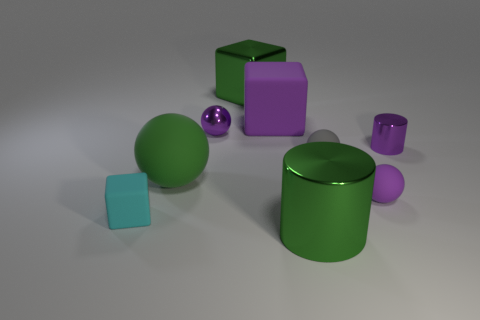What is the material of the big object that is the same color as the metal sphere?
Provide a short and direct response. Rubber. What is the size of the cylinder that is the same color as the large sphere?
Give a very brief answer. Large. There is a large rubber object that is right of the green cube; is its color the same as the cylinder behind the tiny cyan matte thing?
Offer a very short reply. Yes. Is there any other thing that has the same color as the small cylinder?
Provide a succinct answer. Yes. Does the big matte sphere have the same color as the big metal cylinder?
Make the answer very short. Yes. The purple block is what size?
Provide a succinct answer. Large. What size is the purple ball that is the same material as the cyan cube?
Your answer should be very brief. Small. Is the size of the metallic object to the right of the green cylinder the same as the large cylinder?
Give a very brief answer. No. What shape is the big metallic thing that is in front of the gray object that is behind the small object to the left of the tiny purple metallic sphere?
Offer a very short reply. Cylinder. How many things are either big brown matte balls or tiny purple objects that are to the right of the big green metallic cylinder?
Provide a short and direct response. 2. 